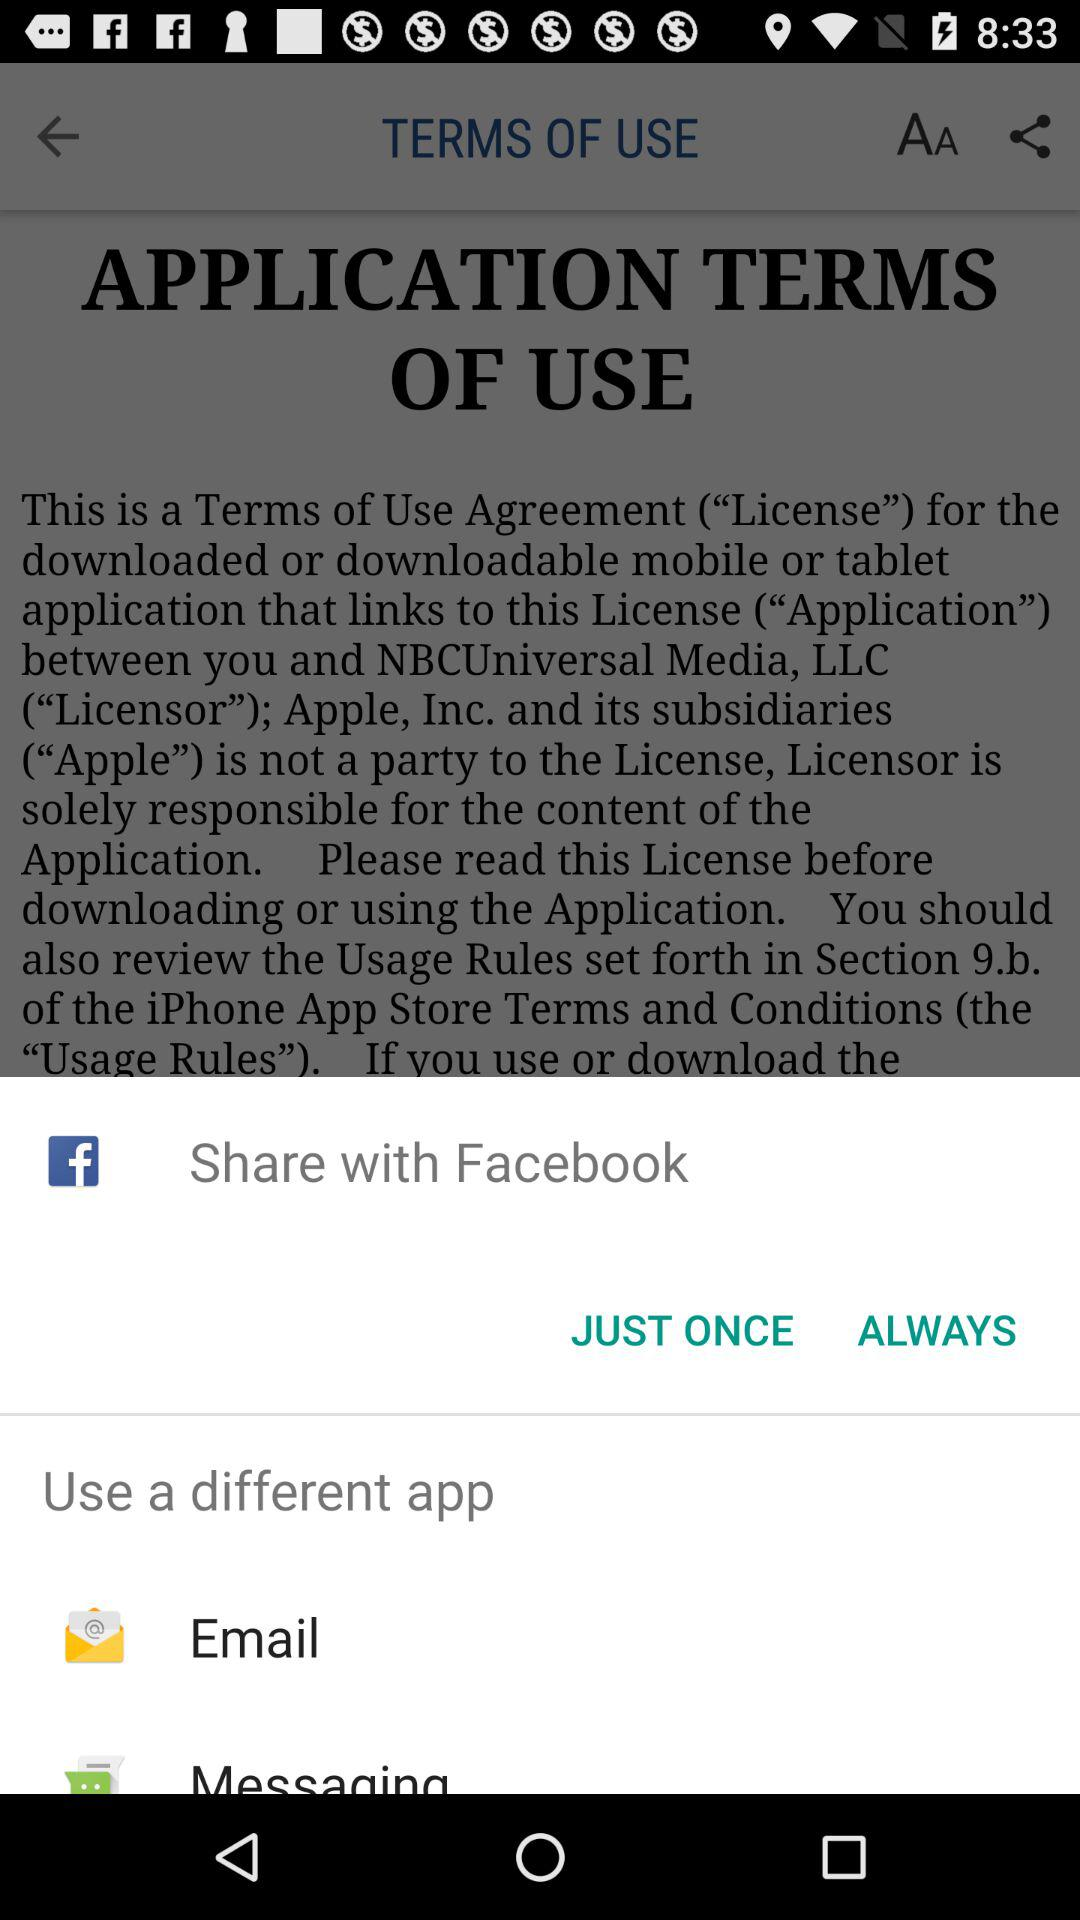What are the options to share? The options are "Facebook", "Email", and "Messaging". 